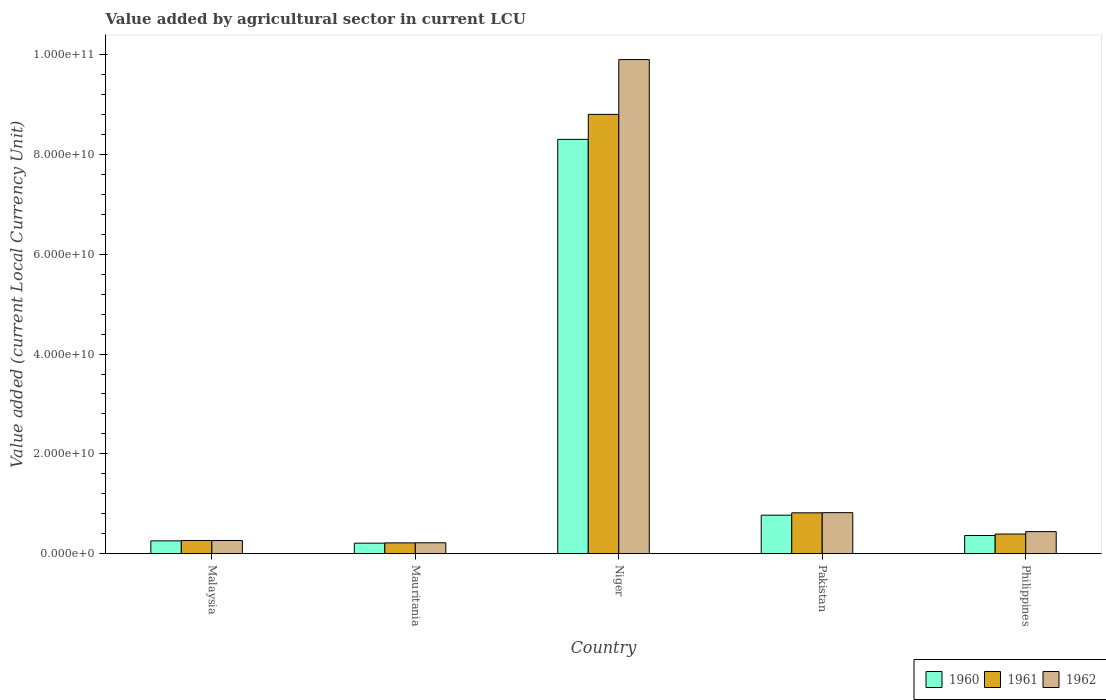How many groups of bars are there?
Your answer should be compact. 5. How many bars are there on the 1st tick from the right?
Offer a very short reply. 3. What is the label of the 5th group of bars from the left?
Ensure brevity in your answer.  Philippines. What is the value added by agricultural sector in 1960 in Pakistan?
Provide a short and direct response. 7.71e+09. Across all countries, what is the maximum value added by agricultural sector in 1962?
Offer a very short reply. 9.90e+1. Across all countries, what is the minimum value added by agricultural sector in 1961?
Your answer should be very brief. 2.16e+09. In which country was the value added by agricultural sector in 1962 maximum?
Ensure brevity in your answer.  Niger. In which country was the value added by agricultural sector in 1962 minimum?
Your answer should be very brief. Mauritania. What is the total value added by agricultural sector in 1960 in the graph?
Offer a very short reply. 9.90e+1. What is the difference between the value added by agricultural sector in 1961 in Niger and that in Philippines?
Your response must be concise. 8.41e+1. What is the difference between the value added by agricultural sector in 1960 in Mauritania and the value added by agricultural sector in 1961 in Malaysia?
Provide a succinct answer. -5.39e+08. What is the average value added by agricultural sector in 1961 per country?
Keep it short and to the point. 2.10e+1. What is the difference between the value added by agricultural sector of/in 1961 and value added by agricultural sector of/in 1962 in Niger?
Provide a succinct answer. -1.10e+1. What is the ratio of the value added by agricultural sector in 1960 in Niger to that in Philippines?
Your answer should be compact. 22.82. Is the difference between the value added by agricultural sector in 1961 in Malaysia and Philippines greater than the difference between the value added by agricultural sector in 1962 in Malaysia and Philippines?
Provide a short and direct response. Yes. What is the difference between the highest and the second highest value added by agricultural sector in 1960?
Offer a terse response. 4.07e+09. What is the difference between the highest and the lowest value added by agricultural sector in 1961?
Keep it short and to the point. 8.59e+1. Is the sum of the value added by agricultural sector in 1962 in Mauritania and Niger greater than the maximum value added by agricultural sector in 1961 across all countries?
Give a very brief answer. Yes. Are all the bars in the graph horizontal?
Give a very brief answer. No. How many countries are there in the graph?
Give a very brief answer. 5. What is the difference between two consecutive major ticks on the Y-axis?
Give a very brief answer. 2.00e+1. Are the values on the major ticks of Y-axis written in scientific E-notation?
Provide a short and direct response. Yes. Does the graph contain any zero values?
Make the answer very short. No. How are the legend labels stacked?
Offer a terse response. Horizontal. What is the title of the graph?
Ensure brevity in your answer.  Value added by agricultural sector in current LCU. What is the label or title of the Y-axis?
Give a very brief answer. Value added (current Local Currency Unit). What is the Value added (current Local Currency Unit) in 1960 in Malaysia?
Give a very brief answer. 2.56e+09. What is the Value added (current Local Currency Unit) in 1961 in Malaysia?
Give a very brief answer. 2.64e+09. What is the Value added (current Local Currency Unit) in 1962 in Malaysia?
Offer a very short reply. 2.63e+09. What is the Value added (current Local Currency Unit) of 1960 in Mauritania?
Provide a short and direct response. 2.10e+09. What is the Value added (current Local Currency Unit) of 1961 in Mauritania?
Offer a terse response. 2.16e+09. What is the Value added (current Local Currency Unit) in 1962 in Mauritania?
Offer a very short reply. 2.18e+09. What is the Value added (current Local Currency Unit) in 1960 in Niger?
Give a very brief answer. 8.30e+1. What is the Value added (current Local Currency Unit) of 1961 in Niger?
Offer a very short reply. 8.80e+1. What is the Value added (current Local Currency Unit) of 1962 in Niger?
Make the answer very short. 9.90e+1. What is the Value added (current Local Currency Unit) of 1960 in Pakistan?
Give a very brief answer. 7.71e+09. What is the Value added (current Local Currency Unit) in 1961 in Pakistan?
Your response must be concise. 8.18e+09. What is the Value added (current Local Currency Unit) of 1962 in Pakistan?
Make the answer very short. 8.22e+09. What is the Value added (current Local Currency Unit) in 1960 in Philippines?
Your answer should be very brief. 3.64e+09. What is the Value added (current Local Currency Unit) of 1961 in Philippines?
Offer a very short reply. 3.94e+09. What is the Value added (current Local Currency Unit) of 1962 in Philippines?
Ensure brevity in your answer.  4.42e+09. Across all countries, what is the maximum Value added (current Local Currency Unit) in 1960?
Your response must be concise. 8.30e+1. Across all countries, what is the maximum Value added (current Local Currency Unit) of 1961?
Keep it short and to the point. 8.80e+1. Across all countries, what is the maximum Value added (current Local Currency Unit) of 1962?
Offer a very short reply. 9.90e+1. Across all countries, what is the minimum Value added (current Local Currency Unit) in 1960?
Your answer should be very brief. 2.10e+09. Across all countries, what is the minimum Value added (current Local Currency Unit) in 1961?
Provide a succinct answer. 2.16e+09. Across all countries, what is the minimum Value added (current Local Currency Unit) of 1962?
Provide a short and direct response. 2.18e+09. What is the total Value added (current Local Currency Unit) of 1960 in the graph?
Offer a very short reply. 9.90e+1. What is the total Value added (current Local Currency Unit) in 1961 in the graph?
Offer a very short reply. 1.05e+11. What is the total Value added (current Local Currency Unit) in 1962 in the graph?
Your answer should be compact. 1.16e+11. What is the difference between the Value added (current Local Currency Unit) in 1960 in Malaysia and that in Mauritania?
Make the answer very short. 4.61e+08. What is the difference between the Value added (current Local Currency Unit) of 1961 in Malaysia and that in Mauritania?
Your response must be concise. 4.82e+08. What is the difference between the Value added (current Local Currency Unit) of 1962 in Malaysia and that in Mauritania?
Your answer should be compact. 4.54e+08. What is the difference between the Value added (current Local Currency Unit) of 1960 in Malaysia and that in Niger?
Your response must be concise. -8.05e+1. What is the difference between the Value added (current Local Currency Unit) of 1961 in Malaysia and that in Niger?
Give a very brief answer. -8.54e+1. What is the difference between the Value added (current Local Currency Unit) in 1962 in Malaysia and that in Niger?
Keep it short and to the point. -9.64e+1. What is the difference between the Value added (current Local Currency Unit) in 1960 in Malaysia and that in Pakistan?
Give a very brief answer. -5.15e+09. What is the difference between the Value added (current Local Currency Unit) in 1961 in Malaysia and that in Pakistan?
Provide a short and direct response. -5.54e+09. What is the difference between the Value added (current Local Currency Unit) in 1962 in Malaysia and that in Pakistan?
Offer a terse response. -5.58e+09. What is the difference between the Value added (current Local Currency Unit) in 1960 in Malaysia and that in Philippines?
Provide a succinct answer. -1.07e+09. What is the difference between the Value added (current Local Currency Unit) of 1961 in Malaysia and that in Philippines?
Offer a terse response. -1.29e+09. What is the difference between the Value added (current Local Currency Unit) in 1962 in Malaysia and that in Philippines?
Ensure brevity in your answer.  -1.78e+09. What is the difference between the Value added (current Local Currency Unit) in 1960 in Mauritania and that in Niger?
Your response must be concise. -8.09e+1. What is the difference between the Value added (current Local Currency Unit) of 1961 in Mauritania and that in Niger?
Ensure brevity in your answer.  -8.59e+1. What is the difference between the Value added (current Local Currency Unit) in 1962 in Mauritania and that in Niger?
Ensure brevity in your answer.  -9.68e+1. What is the difference between the Value added (current Local Currency Unit) of 1960 in Mauritania and that in Pakistan?
Your answer should be compact. -5.61e+09. What is the difference between the Value added (current Local Currency Unit) of 1961 in Mauritania and that in Pakistan?
Ensure brevity in your answer.  -6.02e+09. What is the difference between the Value added (current Local Currency Unit) of 1962 in Mauritania and that in Pakistan?
Keep it short and to the point. -6.04e+09. What is the difference between the Value added (current Local Currency Unit) of 1960 in Mauritania and that in Philippines?
Offer a very short reply. -1.54e+09. What is the difference between the Value added (current Local Currency Unit) of 1961 in Mauritania and that in Philippines?
Give a very brief answer. -1.78e+09. What is the difference between the Value added (current Local Currency Unit) of 1962 in Mauritania and that in Philippines?
Offer a terse response. -2.24e+09. What is the difference between the Value added (current Local Currency Unit) in 1960 in Niger and that in Pakistan?
Provide a succinct answer. 7.53e+1. What is the difference between the Value added (current Local Currency Unit) of 1961 in Niger and that in Pakistan?
Ensure brevity in your answer.  7.98e+1. What is the difference between the Value added (current Local Currency Unit) in 1962 in Niger and that in Pakistan?
Provide a short and direct response. 9.08e+1. What is the difference between the Value added (current Local Currency Unit) in 1960 in Niger and that in Philippines?
Ensure brevity in your answer.  7.94e+1. What is the difference between the Value added (current Local Currency Unit) in 1961 in Niger and that in Philippines?
Make the answer very short. 8.41e+1. What is the difference between the Value added (current Local Currency Unit) in 1962 in Niger and that in Philippines?
Your answer should be very brief. 9.46e+1. What is the difference between the Value added (current Local Currency Unit) of 1960 in Pakistan and that in Philippines?
Provide a short and direct response. 4.07e+09. What is the difference between the Value added (current Local Currency Unit) in 1961 in Pakistan and that in Philippines?
Provide a succinct answer. 4.25e+09. What is the difference between the Value added (current Local Currency Unit) in 1962 in Pakistan and that in Philippines?
Provide a short and direct response. 3.80e+09. What is the difference between the Value added (current Local Currency Unit) of 1960 in Malaysia and the Value added (current Local Currency Unit) of 1961 in Mauritania?
Offer a very short reply. 4.04e+08. What is the difference between the Value added (current Local Currency Unit) in 1960 in Malaysia and the Value added (current Local Currency Unit) in 1962 in Mauritania?
Provide a succinct answer. 3.86e+08. What is the difference between the Value added (current Local Currency Unit) of 1961 in Malaysia and the Value added (current Local Currency Unit) of 1962 in Mauritania?
Provide a succinct answer. 4.63e+08. What is the difference between the Value added (current Local Currency Unit) in 1960 in Malaysia and the Value added (current Local Currency Unit) in 1961 in Niger?
Offer a very short reply. -8.55e+1. What is the difference between the Value added (current Local Currency Unit) in 1960 in Malaysia and the Value added (current Local Currency Unit) in 1962 in Niger?
Offer a terse response. -9.64e+1. What is the difference between the Value added (current Local Currency Unit) of 1961 in Malaysia and the Value added (current Local Currency Unit) of 1962 in Niger?
Offer a very short reply. -9.64e+1. What is the difference between the Value added (current Local Currency Unit) in 1960 in Malaysia and the Value added (current Local Currency Unit) in 1961 in Pakistan?
Your response must be concise. -5.62e+09. What is the difference between the Value added (current Local Currency Unit) in 1960 in Malaysia and the Value added (current Local Currency Unit) in 1962 in Pakistan?
Provide a short and direct response. -5.65e+09. What is the difference between the Value added (current Local Currency Unit) of 1961 in Malaysia and the Value added (current Local Currency Unit) of 1962 in Pakistan?
Keep it short and to the point. -5.57e+09. What is the difference between the Value added (current Local Currency Unit) of 1960 in Malaysia and the Value added (current Local Currency Unit) of 1961 in Philippines?
Provide a succinct answer. -1.37e+09. What is the difference between the Value added (current Local Currency Unit) in 1960 in Malaysia and the Value added (current Local Currency Unit) in 1962 in Philippines?
Offer a very short reply. -1.85e+09. What is the difference between the Value added (current Local Currency Unit) in 1961 in Malaysia and the Value added (current Local Currency Unit) in 1962 in Philippines?
Offer a terse response. -1.77e+09. What is the difference between the Value added (current Local Currency Unit) in 1960 in Mauritania and the Value added (current Local Currency Unit) in 1961 in Niger?
Give a very brief answer. -8.59e+1. What is the difference between the Value added (current Local Currency Unit) of 1960 in Mauritania and the Value added (current Local Currency Unit) of 1962 in Niger?
Keep it short and to the point. -9.69e+1. What is the difference between the Value added (current Local Currency Unit) in 1961 in Mauritania and the Value added (current Local Currency Unit) in 1962 in Niger?
Offer a terse response. -9.69e+1. What is the difference between the Value added (current Local Currency Unit) in 1960 in Mauritania and the Value added (current Local Currency Unit) in 1961 in Pakistan?
Your answer should be compact. -6.08e+09. What is the difference between the Value added (current Local Currency Unit) of 1960 in Mauritania and the Value added (current Local Currency Unit) of 1962 in Pakistan?
Your answer should be very brief. -6.11e+09. What is the difference between the Value added (current Local Currency Unit) in 1961 in Mauritania and the Value added (current Local Currency Unit) in 1962 in Pakistan?
Your answer should be compact. -6.06e+09. What is the difference between the Value added (current Local Currency Unit) in 1960 in Mauritania and the Value added (current Local Currency Unit) in 1961 in Philippines?
Your answer should be very brief. -1.83e+09. What is the difference between the Value added (current Local Currency Unit) of 1960 in Mauritania and the Value added (current Local Currency Unit) of 1962 in Philippines?
Offer a terse response. -2.31e+09. What is the difference between the Value added (current Local Currency Unit) of 1961 in Mauritania and the Value added (current Local Currency Unit) of 1962 in Philippines?
Your answer should be compact. -2.26e+09. What is the difference between the Value added (current Local Currency Unit) of 1960 in Niger and the Value added (current Local Currency Unit) of 1961 in Pakistan?
Give a very brief answer. 7.48e+1. What is the difference between the Value added (current Local Currency Unit) in 1960 in Niger and the Value added (current Local Currency Unit) in 1962 in Pakistan?
Make the answer very short. 7.48e+1. What is the difference between the Value added (current Local Currency Unit) in 1961 in Niger and the Value added (current Local Currency Unit) in 1962 in Pakistan?
Provide a succinct answer. 7.98e+1. What is the difference between the Value added (current Local Currency Unit) of 1960 in Niger and the Value added (current Local Currency Unit) of 1961 in Philippines?
Provide a succinct answer. 7.91e+1. What is the difference between the Value added (current Local Currency Unit) in 1960 in Niger and the Value added (current Local Currency Unit) in 1962 in Philippines?
Offer a terse response. 7.86e+1. What is the difference between the Value added (current Local Currency Unit) of 1961 in Niger and the Value added (current Local Currency Unit) of 1962 in Philippines?
Offer a very short reply. 8.36e+1. What is the difference between the Value added (current Local Currency Unit) in 1960 in Pakistan and the Value added (current Local Currency Unit) in 1961 in Philippines?
Provide a short and direct response. 3.78e+09. What is the difference between the Value added (current Local Currency Unit) of 1960 in Pakistan and the Value added (current Local Currency Unit) of 1962 in Philippines?
Ensure brevity in your answer.  3.29e+09. What is the difference between the Value added (current Local Currency Unit) in 1961 in Pakistan and the Value added (current Local Currency Unit) in 1962 in Philippines?
Offer a terse response. 3.77e+09. What is the average Value added (current Local Currency Unit) in 1960 per country?
Make the answer very short. 1.98e+1. What is the average Value added (current Local Currency Unit) of 1961 per country?
Your answer should be very brief. 2.10e+1. What is the average Value added (current Local Currency Unit) of 1962 per country?
Your response must be concise. 2.33e+1. What is the difference between the Value added (current Local Currency Unit) of 1960 and Value added (current Local Currency Unit) of 1961 in Malaysia?
Provide a succinct answer. -7.78e+07. What is the difference between the Value added (current Local Currency Unit) in 1960 and Value added (current Local Currency Unit) in 1962 in Malaysia?
Offer a very short reply. -6.83e+07. What is the difference between the Value added (current Local Currency Unit) of 1961 and Value added (current Local Currency Unit) of 1962 in Malaysia?
Keep it short and to the point. 9.46e+06. What is the difference between the Value added (current Local Currency Unit) of 1960 and Value added (current Local Currency Unit) of 1961 in Mauritania?
Your response must be concise. -5.68e+07. What is the difference between the Value added (current Local Currency Unit) in 1960 and Value added (current Local Currency Unit) in 1962 in Mauritania?
Give a very brief answer. -7.58e+07. What is the difference between the Value added (current Local Currency Unit) in 1961 and Value added (current Local Currency Unit) in 1962 in Mauritania?
Give a very brief answer. -1.89e+07. What is the difference between the Value added (current Local Currency Unit) of 1960 and Value added (current Local Currency Unit) of 1961 in Niger?
Your response must be concise. -5.01e+09. What is the difference between the Value added (current Local Currency Unit) in 1960 and Value added (current Local Currency Unit) in 1962 in Niger?
Ensure brevity in your answer.  -1.60e+1. What is the difference between the Value added (current Local Currency Unit) of 1961 and Value added (current Local Currency Unit) of 1962 in Niger?
Your answer should be very brief. -1.10e+1. What is the difference between the Value added (current Local Currency Unit) in 1960 and Value added (current Local Currency Unit) in 1961 in Pakistan?
Offer a very short reply. -4.73e+08. What is the difference between the Value added (current Local Currency Unit) in 1960 and Value added (current Local Currency Unit) in 1962 in Pakistan?
Provide a short and direct response. -5.05e+08. What is the difference between the Value added (current Local Currency Unit) of 1961 and Value added (current Local Currency Unit) of 1962 in Pakistan?
Give a very brief answer. -3.20e+07. What is the difference between the Value added (current Local Currency Unit) in 1960 and Value added (current Local Currency Unit) in 1961 in Philippines?
Offer a terse response. -2.97e+08. What is the difference between the Value added (current Local Currency Unit) in 1960 and Value added (current Local Currency Unit) in 1962 in Philippines?
Keep it short and to the point. -7.78e+08. What is the difference between the Value added (current Local Currency Unit) of 1961 and Value added (current Local Currency Unit) of 1962 in Philippines?
Give a very brief answer. -4.81e+08. What is the ratio of the Value added (current Local Currency Unit) of 1960 in Malaysia to that in Mauritania?
Your answer should be compact. 1.22. What is the ratio of the Value added (current Local Currency Unit) in 1961 in Malaysia to that in Mauritania?
Make the answer very short. 1.22. What is the ratio of the Value added (current Local Currency Unit) of 1962 in Malaysia to that in Mauritania?
Keep it short and to the point. 1.21. What is the ratio of the Value added (current Local Currency Unit) in 1960 in Malaysia to that in Niger?
Make the answer very short. 0.03. What is the ratio of the Value added (current Local Currency Unit) in 1961 in Malaysia to that in Niger?
Provide a short and direct response. 0.03. What is the ratio of the Value added (current Local Currency Unit) in 1962 in Malaysia to that in Niger?
Make the answer very short. 0.03. What is the ratio of the Value added (current Local Currency Unit) of 1960 in Malaysia to that in Pakistan?
Provide a succinct answer. 0.33. What is the ratio of the Value added (current Local Currency Unit) of 1961 in Malaysia to that in Pakistan?
Ensure brevity in your answer.  0.32. What is the ratio of the Value added (current Local Currency Unit) in 1962 in Malaysia to that in Pakistan?
Your answer should be compact. 0.32. What is the ratio of the Value added (current Local Currency Unit) in 1960 in Malaysia to that in Philippines?
Your answer should be compact. 0.7. What is the ratio of the Value added (current Local Currency Unit) of 1961 in Malaysia to that in Philippines?
Make the answer very short. 0.67. What is the ratio of the Value added (current Local Currency Unit) in 1962 in Malaysia to that in Philippines?
Provide a short and direct response. 0.6. What is the ratio of the Value added (current Local Currency Unit) of 1960 in Mauritania to that in Niger?
Your answer should be compact. 0.03. What is the ratio of the Value added (current Local Currency Unit) in 1961 in Mauritania to that in Niger?
Provide a succinct answer. 0.02. What is the ratio of the Value added (current Local Currency Unit) in 1962 in Mauritania to that in Niger?
Give a very brief answer. 0.02. What is the ratio of the Value added (current Local Currency Unit) of 1960 in Mauritania to that in Pakistan?
Provide a succinct answer. 0.27. What is the ratio of the Value added (current Local Currency Unit) of 1961 in Mauritania to that in Pakistan?
Provide a short and direct response. 0.26. What is the ratio of the Value added (current Local Currency Unit) of 1962 in Mauritania to that in Pakistan?
Your answer should be compact. 0.27. What is the ratio of the Value added (current Local Currency Unit) of 1960 in Mauritania to that in Philippines?
Keep it short and to the point. 0.58. What is the ratio of the Value added (current Local Currency Unit) in 1961 in Mauritania to that in Philippines?
Your response must be concise. 0.55. What is the ratio of the Value added (current Local Currency Unit) of 1962 in Mauritania to that in Philippines?
Give a very brief answer. 0.49. What is the ratio of the Value added (current Local Currency Unit) in 1960 in Niger to that in Pakistan?
Offer a terse response. 10.77. What is the ratio of the Value added (current Local Currency Unit) in 1961 in Niger to that in Pakistan?
Provide a short and direct response. 10.76. What is the ratio of the Value added (current Local Currency Unit) in 1962 in Niger to that in Pakistan?
Provide a short and direct response. 12.05. What is the ratio of the Value added (current Local Currency Unit) of 1960 in Niger to that in Philippines?
Your answer should be compact. 22.82. What is the ratio of the Value added (current Local Currency Unit) of 1961 in Niger to that in Philippines?
Provide a succinct answer. 22.37. What is the ratio of the Value added (current Local Currency Unit) of 1962 in Niger to that in Philippines?
Ensure brevity in your answer.  22.42. What is the ratio of the Value added (current Local Currency Unit) of 1960 in Pakistan to that in Philippines?
Provide a short and direct response. 2.12. What is the ratio of the Value added (current Local Currency Unit) in 1961 in Pakistan to that in Philippines?
Your response must be concise. 2.08. What is the ratio of the Value added (current Local Currency Unit) of 1962 in Pakistan to that in Philippines?
Offer a terse response. 1.86. What is the difference between the highest and the second highest Value added (current Local Currency Unit) of 1960?
Offer a very short reply. 7.53e+1. What is the difference between the highest and the second highest Value added (current Local Currency Unit) in 1961?
Your answer should be very brief. 7.98e+1. What is the difference between the highest and the second highest Value added (current Local Currency Unit) in 1962?
Provide a short and direct response. 9.08e+1. What is the difference between the highest and the lowest Value added (current Local Currency Unit) of 1960?
Ensure brevity in your answer.  8.09e+1. What is the difference between the highest and the lowest Value added (current Local Currency Unit) in 1961?
Keep it short and to the point. 8.59e+1. What is the difference between the highest and the lowest Value added (current Local Currency Unit) in 1962?
Offer a very short reply. 9.68e+1. 